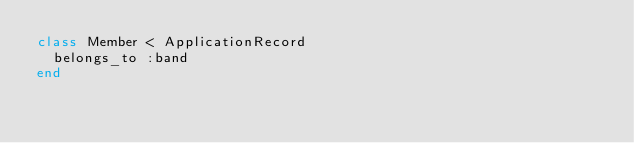<code> <loc_0><loc_0><loc_500><loc_500><_Ruby_>class Member < ApplicationRecord
  belongs_to :band
end
</code> 